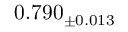Convert formula to latex. <formula><loc_0><loc_0><loc_500><loc_500>0 . 7 9 0 _ { \pm 0 . 0 1 3 }</formula> 